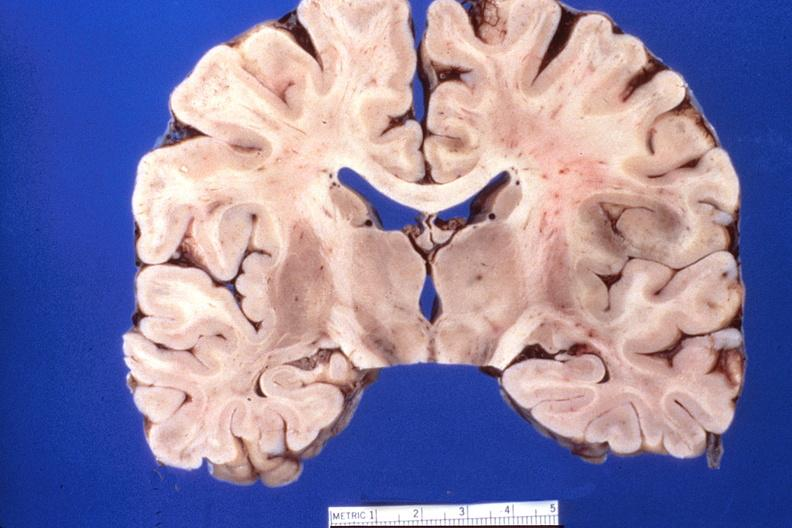does bone, mandible show brain, herpes encephalitis?
Answer the question using a single word or phrase. No 